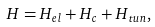<formula> <loc_0><loc_0><loc_500><loc_500>H = H _ { e l } + H _ { c } + H _ { t u n } ,</formula> 